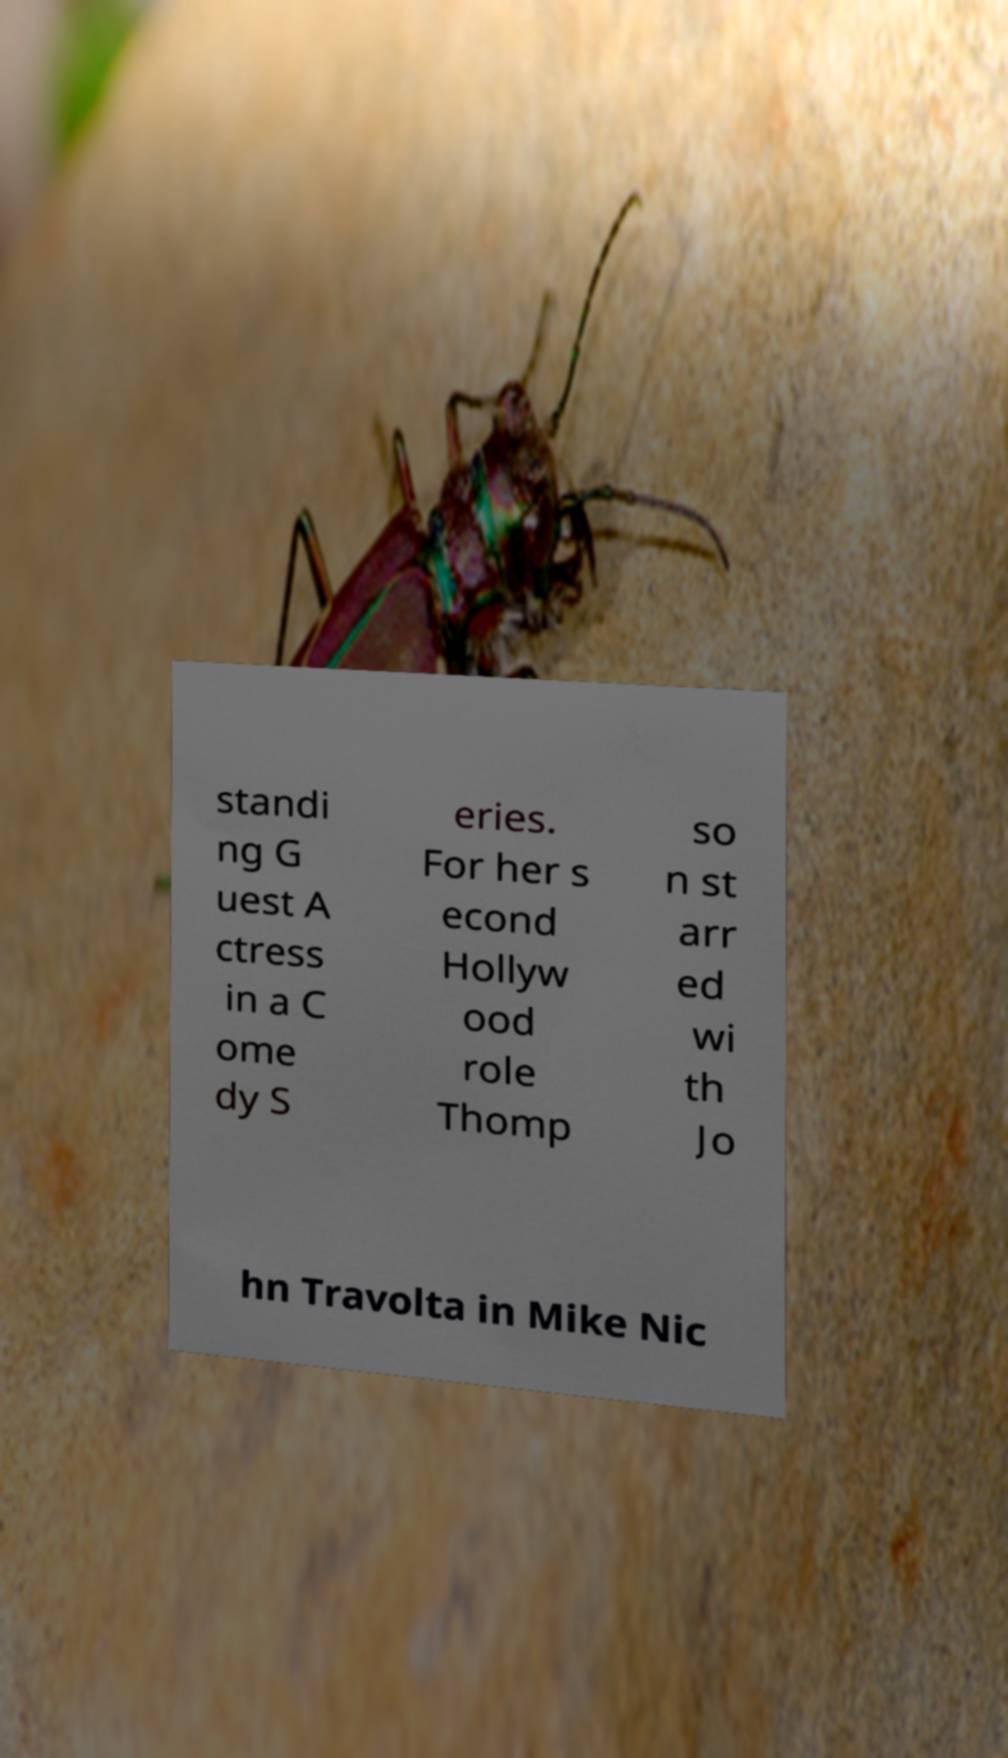Can you accurately transcribe the text from the provided image for me? standi ng G uest A ctress in a C ome dy S eries. For her s econd Hollyw ood role Thomp so n st arr ed wi th Jo hn Travolta in Mike Nic 